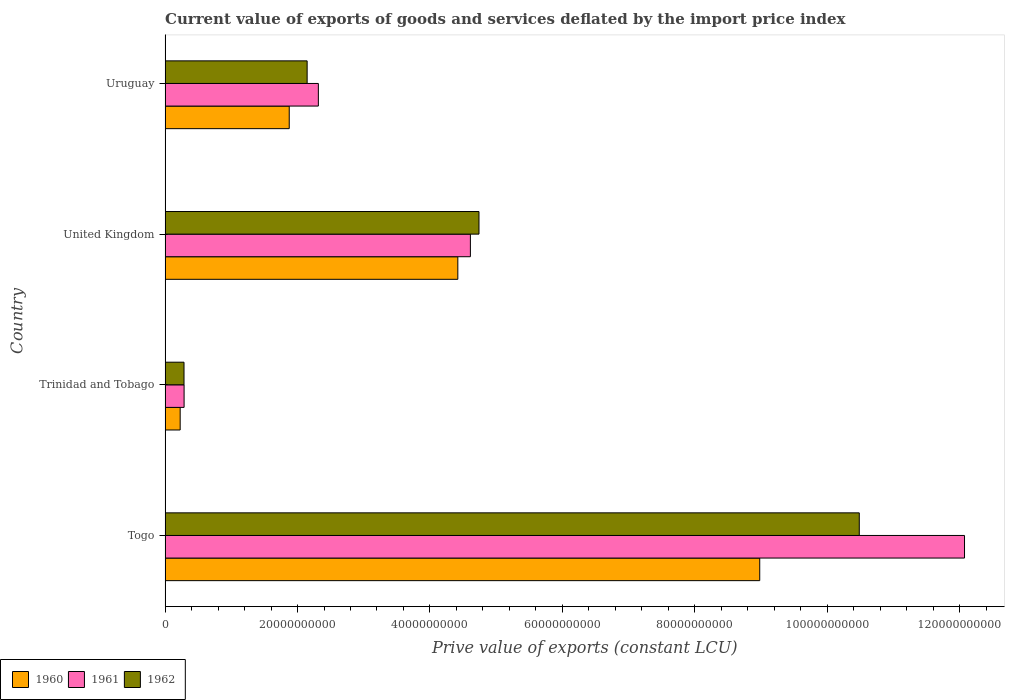How many groups of bars are there?
Ensure brevity in your answer.  4. Are the number of bars per tick equal to the number of legend labels?
Offer a terse response. Yes. Are the number of bars on each tick of the Y-axis equal?
Your response must be concise. Yes. How many bars are there on the 4th tick from the bottom?
Offer a terse response. 3. What is the label of the 4th group of bars from the top?
Your answer should be compact. Togo. What is the prive value of exports in 1960 in Trinidad and Tobago?
Give a very brief answer. 2.28e+09. Across all countries, what is the maximum prive value of exports in 1962?
Provide a short and direct response. 1.05e+11. Across all countries, what is the minimum prive value of exports in 1962?
Your answer should be compact. 2.86e+09. In which country was the prive value of exports in 1962 maximum?
Provide a short and direct response. Togo. In which country was the prive value of exports in 1962 minimum?
Offer a terse response. Trinidad and Tobago. What is the total prive value of exports in 1960 in the graph?
Provide a short and direct response. 1.55e+11. What is the difference between the prive value of exports in 1960 in Trinidad and Tobago and that in United Kingdom?
Your answer should be compact. -4.19e+1. What is the difference between the prive value of exports in 1962 in Togo and the prive value of exports in 1960 in Trinidad and Tobago?
Give a very brief answer. 1.03e+11. What is the average prive value of exports in 1962 per country?
Your answer should be compact. 4.41e+1. What is the difference between the prive value of exports in 1960 and prive value of exports in 1961 in Trinidad and Tobago?
Your answer should be very brief. -5.92e+08. What is the ratio of the prive value of exports in 1962 in United Kingdom to that in Uruguay?
Provide a succinct answer. 2.21. What is the difference between the highest and the second highest prive value of exports in 1960?
Your answer should be compact. 4.56e+1. What is the difference between the highest and the lowest prive value of exports in 1960?
Provide a succinct answer. 8.75e+1. In how many countries, is the prive value of exports in 1962 greater than the average prive value of exports in 1962 taken over all countries?
Provide a succinct answer. 2. What does the 2nd bar from the bottom in Togo represents?
Give a very brief answer. 1961. Is it the case that in every country, the sum of the prive value of exports in 1960 and prive value of exports in 1962 is greater than the prive value of exports in 1961?
Provide a short and direct response. Yes. How many bars are there?
Make the answer very short. 12. Are all the bars in the graph horizontal?
Make the answer very short. Yes. What is the difference between two consecutive major ticks on the X-axis?
Offer a terse response. 2.00e+1. Does the graph contain grids?
Offer a very short reply. No. How many legend labels are there?
Your response must be concise. 3. How are the legend labels stacked?
Provide a succinct answer. Horizontal. What is the title of the graph?
Keep it short and to the point. Current value of exports of goods and services deflated by the import price index. What is the label or title of the X-axis?
Keep it short and to the point. Prive value of exports (constant LCU). What is the Prive value of exports (constant LCU) of 1960 in Togo?
Offer a terse response. 8.98e+1. What is the Prive value of exports (constant LCU) of 1961 in Togo?
Offer a very short reply. 1.21e+11. What is the Prive value of exports (constant LCU) in 1962 in Togo?
Provide a short and direct response. 1.05e+11. What is the Prive value of exports (constant LCU) in 1960 in Trinidad and Tobago?
Your answer should be very brief. 2.28e+09. What is the Prive value of exports (constant LCU) in 1961 in Trinidad and Tobago?
Provide a short and direct response. 2.87e+09. What is the Prive value of exports (constant LCU) of 1962 in Trinidad and Tobago?
Provide a short and direct response. 2.86e+09. What is the Prive value of exports (constant LCU) in 1960 in United Kingdom?
Your answer should be compact. 4.42e+1. What is the Prive value of exports (constant LCU) of 1961 in United Kingdom?
Your answer should be compact. 4.61e+1. What is the Prive value of exports (constant LCU) of 1962 in United Kingdom?
Give a very brief answer. 4.74e+1. What is the Prive value of exports (constant LCU) of 1960 in Uruguay?
Your answer should be compact. 1.88e+1. What is the Prive value of exports (constant LCU) in 1961 in Uruguay?
Provide a succinct answer. 2.31e+1. What is the Prive value of exports (constant LCU) in 1962 in Uruguay?
Keep it short and to the point. 2.15e+1. Across all countries, what is the maximum Prive value of exports (constant LCU) in 1960?
Provide a succinct answer. 8.98e+1. Across all countries, what is the maximum Prive value of exports (constant LCU) of 1961?
Your answer should be very brief. 1.21e+11. Across all countries, what is the maximum Prive value of exports (constant LCU) in 1962?
Your answer should be compact. 1.05e+11. Across all countries, what is the minimum Prive value of exports (constant LCU) in 1960?
Offer a terse response. 2.28e+09. Across all countries, what is the minimum Prive value of exports (constant LCU) in 1961?
Offer a terse response. 2.87e+09. Across all countries, what is the minimum Prive value of exports (constant LCU) in 1962?
Your response must be concise. 2.86e+09. What is the total Prive value of exports (constant LCU) of 1960 in the graph?
Offer a terse response. 1.55e+11. What is the total Prive value of exports (constant LCU) in 1961 in the graph?
Your answer should be compact. 1.93e+11. What is the total Prive value of exports (constant LCU) in 1962 in the graph?
Keep it short and to the point. 1.77e+11. What is the difference between the Prive value of exports (constant LCU) of 1960 in Togo and that in Trinidad and Tobago?
Provide a short and direct response. 8.75e+1. What is the difference between the Prive value of exports (constant LCU) of 1961 in Togo and that in Trinidad and Tobago?
Provide a succinct answer. 1.18e+11. What is the difference between the Prive value of exports (constant LCU) in 1962 in Togo and that in Trinidad and Tobago?
Provide a short and direct response. 1.02e+11. What is the difference between the Prive value of exports (constant LCU) in 1960 in Togo and that in United Kingdom?
Your answer should be very brief. 4.56e+1. What is the difference between the Prive value of exports (constant LCU) in 1961 in Togo and that in United Kingdom?
Provide a succinct answer. 7.46e+1. What is the difference between the Prive value of exports (constant LCU) of 1962 in Togo and that in United Kingdom?
Provide a succinct answer. 5.74e+1. What is the difference between the Prive value of exports (constant LCU) of 1960 in Togo and that in Uruguay?
Provide a short and direct response. 7.11e+1. What is the difference between the Prive value of exports (constant LCU) of 1961 in Togo and that in Uruguay?
Make the answer very short. 9.76e+1. What is the difference between the Prive value of exports (constant LCU) in 1962 in Togo and that in Uruguay?
Ensure brevity in your answer.  8.34e+1. What is the difference between the Prive value of exports (constant LCU) of 1960 in Trinidad and Tobago and that in United Kingdom?
Make the answer very short. -4.19e+1. What is the difference between the Prive value of exports (constant LCU) in 1961 in Trinidad and Tobago and that in United Kingdom?
Offer a very short reply. -4.32e+1. What is the difference between the Prive value of exports (constant LCU) in 1962 in Trinidad and Tobago and that in United Kingdom?
Offer a very short reply. -4.46e+1. What is the difference between the Prive value of exports (constant LCU) of 1960 in Trinidad and Tobago and that in Uruguay?
Offer a terse response. -1.65e+1. What is the difference between the Prive value of exports (constant LCU) of 1961 in Trinidad and Tobago and that in Uruguay?
Your answer should be compact. -2.03e+1. What is the difference between the Prive value of exports (constant LCU) of 1962 in Trinidad and Tobago and that in Uruguay?
Keep it short and to the point. -1.86e+1. What is the difference between the Prive value of exports (constant LCU) of 1960 in United Kingdom and that in Uruguay?
Give a very brief answer. 2.55e+1. What is the difference between the Prive value of exports (constant LCU) in 1961 in United Kingdom and that in Uruguay?
Ensure brevity in your answer.  2.30e+1. What is the difference between the Prive value of exports (constant LCU) in 1962 in United Kingdom and that in Uruguay?
Give a very brief answer. 2.60e+1. What is the difference between the Prive value of exports (constant LCU) in 1960 in Togo and the Prive value of exports (constant LCU) in 1961 in Trinidad and Tobago?
Provide a succinct answer. 8.69e+1. What is the difference between the Prive value of exports (constant LCU) of 1960 in Togo and the Prive value of exports (constant LCU) of 1962 in Trinidad and Tobago?
Provide a succinct answer. 8.70e+1. What is the difference between the Prive value of exports (constant LCU) of 1961 in Togo and the Prive value of exports (constant LCU) of 1962 in Trinidad and Tobago?
Provide a succinct answer. 1.18e+11. What is the difference between the Prive value of exports (constant LCU) in 1960 in Togo and the Prive value of exports (constant LCU) in 1961 in United Kingdom?
Offer a terse response. 4.37e+1. What is the difference between the Prive value of exports (constant LCU) of 1960 in Togo and the Prive value of exports (constant LCU) of 1962 in United Kingdom?
Provide a succinct answer. 4.24e+1. What is the difference between the Prive value of exports (constant LCU) of 1961 in Togo and the Prive value of exports (constant LCU) of 1962 in United Kingdom?
Offer a very short reply. 7.33e+1. What is the difference between the Prive value of exports (constant LCU) of 1960 in Togo and the Prive value of exports (constant LCU) of 1961 in Uruguay?
Your response must be concise. 6.67e+1. What is the difference between the Prive value of exports (constant LCU) of 1960 in Togo and the Prive value of exports (constant LCU) of 1962 in Uruguay?
Keep it short and to the point. 6.84e+1. What is the difference between the Prive value of exports (constant LCU) in 1961 in Togo and the Prive value of exports (constant LCU) in 1962 in Uruguay?
Ensure brevity in your answer.  9.93e+1. What is the difference between the Prive value of exports (constant LCU) in 1960 in Trinidad and Tobago and the Prive value of exports (constant LCU) in 1961 in United Kingdom?
Offer a terse response. -4.38e+1. What is the difference between the Prive value of exports (constant LCU) of 1960 in Trinidad and Tobago and the Prive value of exports (constant LCU) of 1962 in United Kingdom?
Provide a short and direct response. -4.51e+1. What is the difference between the Prive value of exports (constant LCU) of 1961 in Trinidad and Tobago and the Prive value of exports (constant LCU) of 1962 in United Kingdom?
Provide a succinct answer. -4.45e+1. What is the difference between the Prive value of exports (constant LCU) in 1960 in Trinidad and Tobago and the Prive value of exports (constant LCU) in 1961 in Uruguay?
Your response must be concise. -2.09e+1. What is the difference between the Prive value of exports (constant LCU) of 1960 in Trinidad and Tobago and the Prive value of exports (constant LCU) of 1962 in Uruguay?
Keep it short and to the point. -1.92e+1. What is the difference between the Prive value of exports (constant LCU) in 1961 in Trinidad and Tobago and the Prive value of exports (constant LCU) in 1962 in Uruguay?
Keep it short and to the point. -1.86e+1. What is the difference between the Prive value of exports (constant LCU) in 1960 in United Kingdom and the Prive value of exports (constant LCU) in 1961 in Uruguay?
Your response must be concise. 2.11e+1. What is the difference between the Prive value of exports (constant LCU) of 1960 in United Kingdom and the Prive value of exports (constant LCU) of 1962 in Uruguay?
Your response must be concise. 2.28e+1. What is the difference between the Prive value of exports (constant LCU) of 1961 in United Kingdom and the Prive value of exports (constant LCU) of 1962 in Uruguay?
Keep it short and to the point. 2.47e+1. What is the average Prive value of exports (constant LCU) of 1960 per country?
Give a very brief answer. 3.88e+1. What is the average Prive value of exports (constant LCU) in 1961 per country?
Offer a very short reply. 4.82e+1. What is the average Prive value of exports (constant LCU) in 1962 per country?
Make the answer very short. 4.41e+1. What is the difference between the Prive value of exports (constant LCU) of 1960 and Prive value of exports (constant LCU) of 1961 in Togo?
Offer a very short reply. -3.09e+1. What is the difference between the Prive value of exports (constant LCU) of 1960 and Prive value of exports (constant LCU) of 1962 in Togo?
Make the answer very short. -1.50e+1. What is the difference between the Prive value of exports (constant LCU) in 1961 and Prive value of exports (constant LCU) in 1962 in Togo?
Your answer should be very brief. 1.59e+1. What is the difference between the Prive value of exports (constant LCU) of 1960 and Prive value of exports (constant LCU) of 1961 in Trinidad and Tobago?
Provide a short and direct response. -5.92e+08. What is the difference between the Prive value of exports (constant LCU) of 1960 and Prive value of exports (constant LCU) of 1962 in Trinidad and Tobago?
Your response must be concise. -5.79e+08. What is the difference between the Prive value of exports (constant LCU) of 1961 and Prive value of exports (constant LCU) of 1962 in Trinidad and Tobago?
Make the answer very short. 1.28e+07. What is the difference between the Prive value of exports (constant LCU) of 1960 and Prive value of exports (constant LCU) of 1961 in United Kingdom?
Provide a short and direct response. -1.90e+09. What is the difference between the Prive value of exports (constant LCU) in 1960 and Prive value of exports (constant LCU) in 1962 in United Kingdom?
Ensure brevity in your answer.  -3.20e+09. What is the difference between the Prive value of exports (constant LCU) in 1961 and Prive value of exports (constant LCU) in 1962 in United Kingdom?
Give a very brief answer. -1.30e+09. What is the difference between the Prive value of exports (constant LCU) of 1960 and Prive value of exports (constant LCU) of 1961 in Uruguay?
Offer a very short reply. -4.40e+09. What is the difference between the Prive value of exports (constant LCU) in 1960 and Prive value of exports (constant LCU) in 1962 in Uruguay?
Make the answer very short. -2.70e+09. What is the difference between the Prive value of exports (constant LCU) of 1961 and Prive value of exports (constant LCU) of 1962 in Uruguay?
Your answer should be compact. 1.70e+09. What is the ratio of the Prive value of exports (constant LCU) of 1960 in Togo to that in Trinidad and Tobago?
Offer a terse response. 39.43. What is the ratio of the Prive value of exports (constant LCU) of 1961 in Togo to that in Trinidad and Tobago?
Keep it short and to the point. 42.08. What is the ratio of the Prive value of exports (constant LCU) in 1962 in Togo to that in Trinidad and Tobago?
Your response must be concise. 36.71. What is the ratio of the Prive value of exports (constant LCU) of 1960 in Togo to that in United Kingdom?
Offer a very short reply. 2.03. What is the ratio of the Prive value of exports (constant LCU) in 1961 in Togo to that in United Kingdom?
Your answer should be compact. 2.62. What is the ratio of the Prive value of exports (constant LCU) in 1962 in Togo to that in United Kingdom?
Keep it short and to the point. 2.21. What is the ratio of the Prive value of exports (constant LCU) of 1960 in Togo to that in Uruguay?
Provide a succinct answer. 4.79. What is the ratio of the Prive value of exports (constant LCU) of 1961 in Togo to that in Uruguay?
Offer a terse response. 5.22. What is the ratio of the Prive value of exports (constant LCU) of 1962 in Togo to that in Uruguay?
Give a very brief answer. 4.89. What is the ratio of the Prive value of exports (constant LCU) of 1960 in Trinidad and Tobago to that in United Kingdom?
Offer a very short reply. 0.05. What is the ratio of the Prive value of exports (constant LCU) in 1961 in Trinidad and Tobago to that in United Kingdom?
Your answer should be very brief. 0.06. What is the ratio of the Prive value of exports (constant LCU) of 1962 in Trinidad and Tobago to that in United Kingdom?
Ensure brevity in your answer.  0.06. What is the ratio of the Prive value of exports (constant LCU) of 1960 in Trinidad and Tobago to that in Uruguay?
Offer a terse response. 0.12. What is the ratio of the Prive value of exports (constant LCU) in 1961 in Trinidad and Tobago to that in Uruguay?
Your answer should be compact. 0.12. What is the ratio of the Prive value of exports (constant LCU) of 1962 in Trinidad and Tobago to that in Uruguay?
Your response must be concise. 0.13. What is the ratio of the Prive value of exports (constant LCU) in 1960 in United Kingdom to that in Uruguay?
Offer a terse response. 2.36. What is the ratio of the Prive value of exports (constant LCU) of 1961 in United Kingdom to that in Uruguay?
Your answer should be very brief. 1.99. What is the ratio of the Prive value of exports (constant LCU) of 1962 in United Kingdom to that in Uruguay?
Your response must be concise. 2.21. What is the difference between the highest and the second highest Prive value of exports (constant LCU) of 1960?
Provide a succinct answer. 4.56e+1. What is the difference between the highest and the second highest Prive value of exports (constant LCU) in 1961?
Provide a succinct answer. 7.46e+1. What is the difference between the highest and the second highest Prive value of exports (constant LCU) in 1962?
Keep it short and to the point. 5.74e+1. What is the difference between the highest and the lowest Prive value of exports (constant LCU) of 1960?
Ensure brevity in your answer.  8.75e+1. What is the difference between the highest and the lowest Prive value of exports (constant LCU) in 1961?
Offer a terse response. 1.18e+11. What is the difference between the highest and the lowest Prive value of exports (constant LCU) in 1962?
Ensure brevity in your answer.  1.02e+11. 